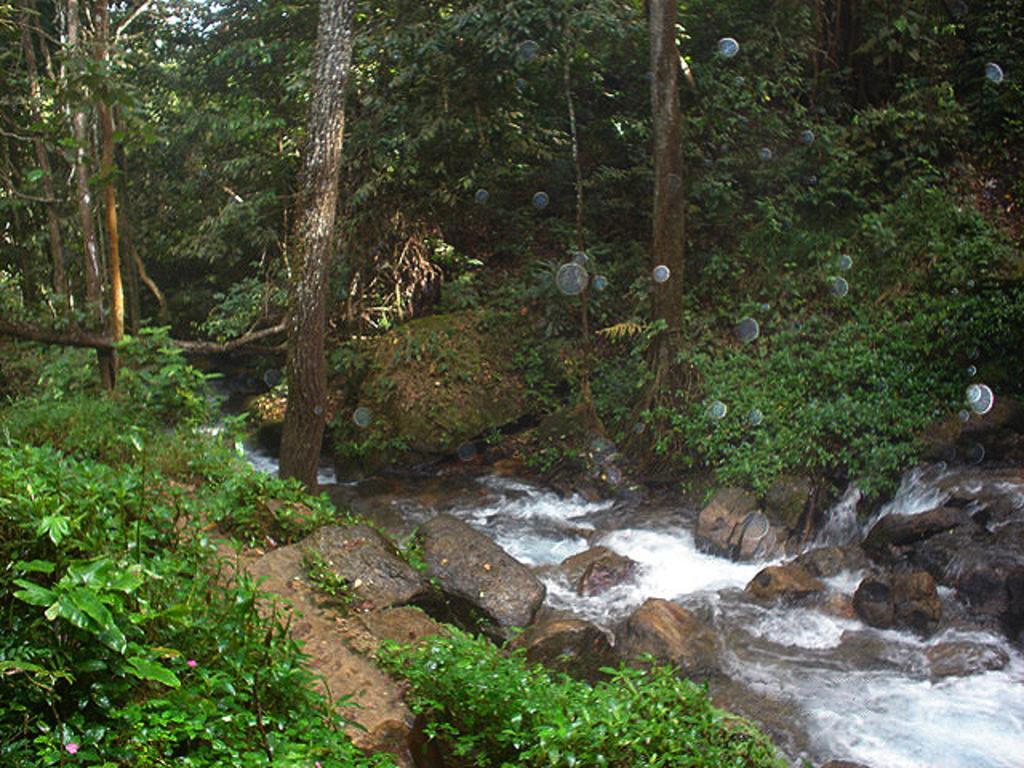How would you summarize this image in a sentence or two? In this picture we can see plants, rocks, water, some objects and in the background we can see trees. 